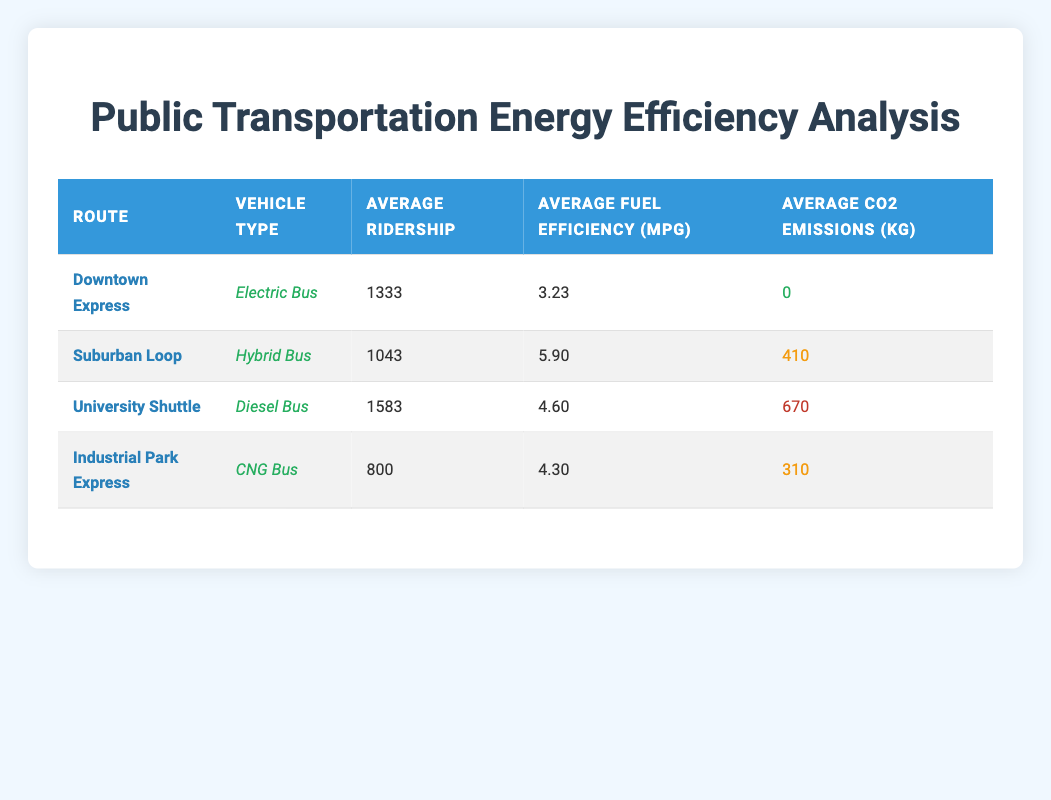What is the average fuel efficiency of the Downtown Express route? There is one entry for the Downtown Express route in the table that shows an average fuel efficiency of 3.23 mpg. Therefore, the average value for this route can be directly retrieved from the table.
Answer: 3.23 mpg What is the total ridership for the University Shuttle across the three months? To find the total ridership for the University Shuttle, we sum the ridership values for each month (January: 1500 + February: 1600 + March: 1650). This gives a total of 1500 + 1600 + 1650 = 4750.
Answer: 4750 Is the emissions level for the Suburban Loop higher than that for the Industrial Park Express? By comparing the CO2 emissions values for both routes (Suburban Loop: 410 kg and Industrial Park Express: 310 kg), we can see that 410 is greater than 310, confirming that the Suburban Loop has higher emissions.
Answer: Yes What is the average ridership for the Hybrid Bus? The Hybrid Bus is used on the Suburban Loop, with ridership figures of 980, 1050, and 1100 from January to March. To calculate the average, we add these values (980 + 1050 + 1100 = 3130) and divide by the number of entries (3), resulting in an average of 3130 / 3 = 1043.33, rounded to 1043.
Answer: 1043 Which vehicle type has the lowest average CO2 emissions? By examining the average CO2 emissions for each vehicle type: Electric Bus (0 kg), Hybrid Bus (410 kg), Diesel Bus (670 kg), and CNG Bus (310 kg), we can determine that the Electric Bus has the lowest emissions with a value of 0 kg.
Answer: Electric Bus What is the percentage increase in ridership for the Downtown Express from January to March? The ridership for Downtown Express in January is 1250 and in March is 1400. To find the percentage increase, we calculate the difference (1400 - 1250 = 150), then divide by the January value (150 / 1250 = 0.12), and multiply by 100 to get the percentage (0.12 x 100 = 12%).
Answer: 12% Is the average fuel efficiency of the University Shuttle higher than that of the Industrial Park Express? The fuel efficiency for the University Shuttle is 4.60 mpg, while for the Industrial Park Express it is 4.30 mpg. Since 4.60 is greater than 4.30, the statement is true.
Answer: Yes What is the total average ridership for all routes in February? We list the ridership for each route in February: Downtown Express (1350), Suburban Loop (1050), University Shuttle (1600), and Industrial Park Express (800). The total ridership is calculated as 1350 + 1050 + 1600 + 800 = 4800. Dividing by 4 gives the average ridership of 4800 / 4 = 1200.
Answer: 1200 